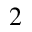<formula> <loc_0><loc_0><loc_500><loc_500>^ { 2 }</formula> 